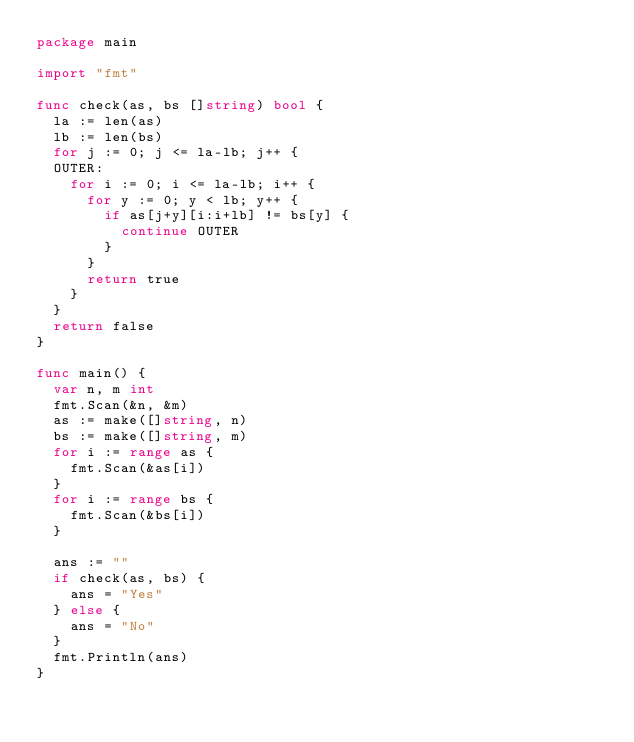Convert code to text. <code><loc_0><loc_0><loc_500><loc_500><_Go_>package main

import "fmt"

func check(as, bs []string) bool {
	la := len(as)
	lb := len(bs)
	for j := 0; j <= la-lb; j++ {
	OUTER:
		for i := 0; i <= la-lb; i++ {
			for y := 0; y < lb; y++ {
				if as[j+y][i:i+lb] != bs[y] {
					continue OUTER
				}
			}
			return true
		}
	}
	return false
}

func main() {
	var n, m int
	fmt.Scan(&n, &m)
	as := make([]string, n)
	bs := make([]string, m)
	for i := range as {
		fmt.Scan(&as[i])
	}
	for i := range bs {
		fmt.Scan(&bs[i])
	}

	ans := ""
	if check(as, bs) {
		ans = "Yes"
	} else {
		ans = "No"
	}
	fmt.Println(ans)
}
</code> 